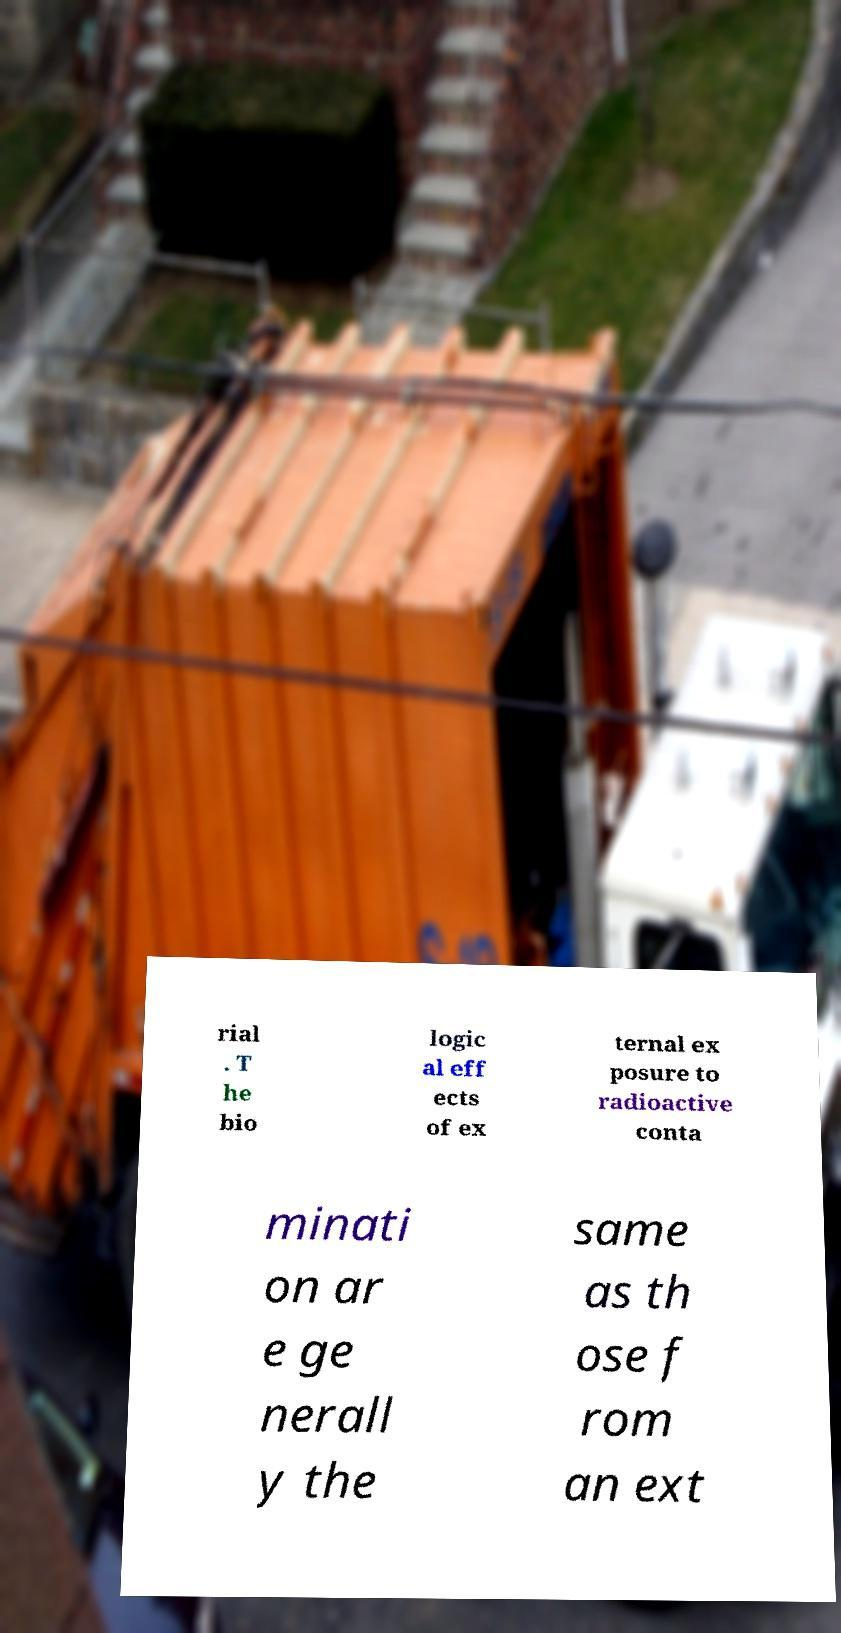Please read and relay the text visible in this image. What does it say? rial . T he bio logic al eff ects of ex ternal ex posure to radioactive conta minati on ar e ge nerall y the same as th ose f rom an ext 